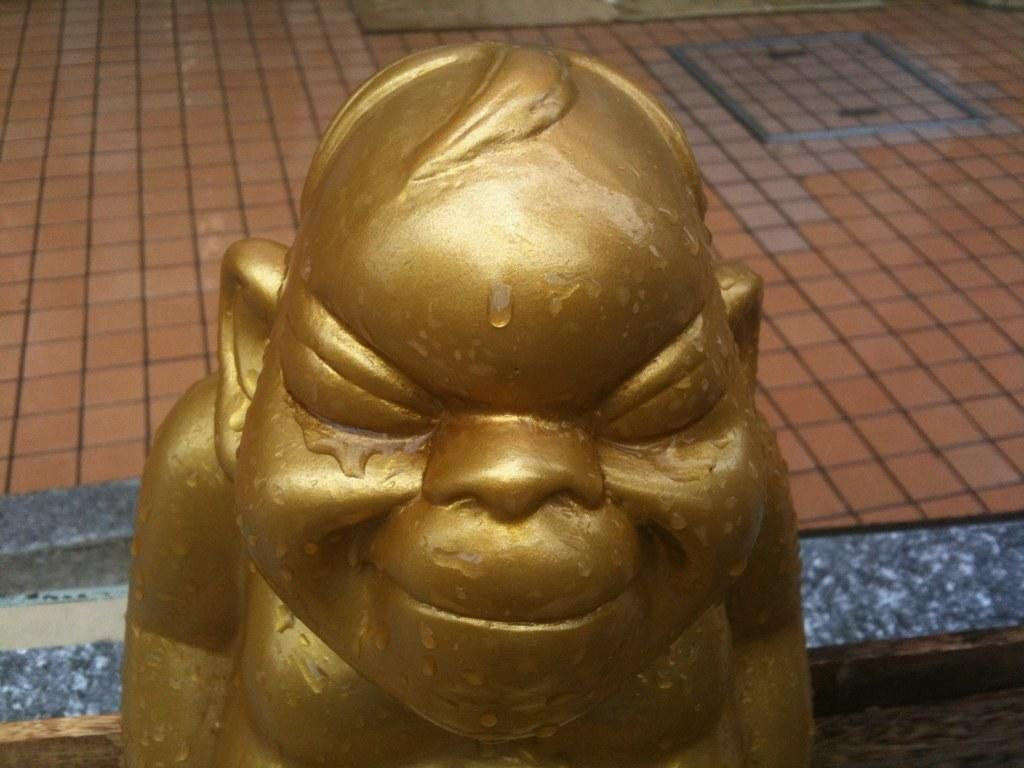What figure is present in the image? There is a laughing Buddha in the image. What is the condition of the laughing Buddha? The laughing Buddha has water on it. What can be seen in the background of the image? There is a floor visible in the background of the image. What type of reading material can be seen in the image? There is no reading material present in the image. Is there a school or playground visible in the image? No, there is no school or playground present in the image. 